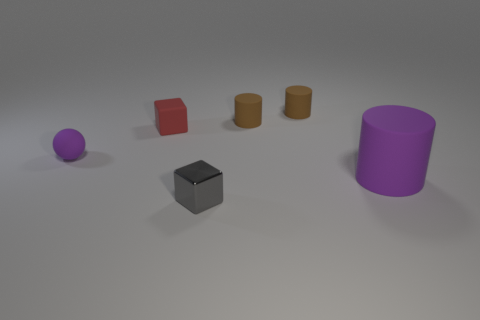Is there anything else that has the same size as the purple matte cylinder?
Ensure brevity in your answer.  No. How many tiny things are either red matte objects or cyan objects?
Your response must be concise. 1. Is the number of tiny purple matte balls right of the large purple rubber object the same as the number of small gray objects that are behind the red object?
Your response must be concise. Yes. How many red things are the same size as the gray cube?
Your answer should be compact. 1. What number of purple objects are tiny matte balls or metallic balls?
Your response must be concise. 1. Are there an equal number of tiny brown matte things in front of the small purple object and small matte cylinders?
Your answer should be very brief. No. What is the size of the matte thing left of the red matte thing?
Give a very brief answer. Small. What number of small brown objects have the same shape as the big rubber thing?
Make the answer very short. 2. What is the material of the object that is both in front of the tiny purple thing and behind the gray metal thing?
Your response must be concise. Rubber. Is the material of the purple sphere the same as the gray thing?
Keep it short and to the point. No. 